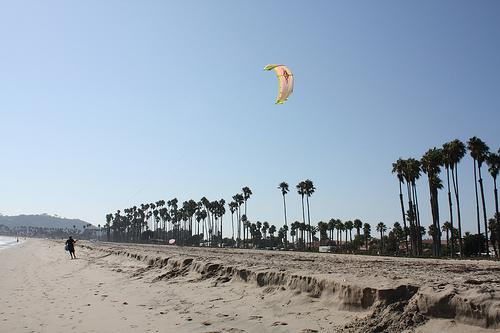Question: what is the man flying?
Choices:
A. A plane.
B. A kite.
C. A balloon.
D. A remote control owl.
Answer with the letter. Answer: B Question: how is the weather?
Choices:
A. Warm.
B. Clear.
C. Cold.
D. Foggy.
Answer with the letter. Answer: B Question: where was this picture taken?
Choices:
A. A forest.
B. The mountains.
C. A beach.
D. A bridge.
Answer with the letter. Answer: C Question: when was this picture taken?
Choices:
A. Morning.
B. Evening.
C. Midnight.
D. Daytime.
Answer with the letter. Answer: D 